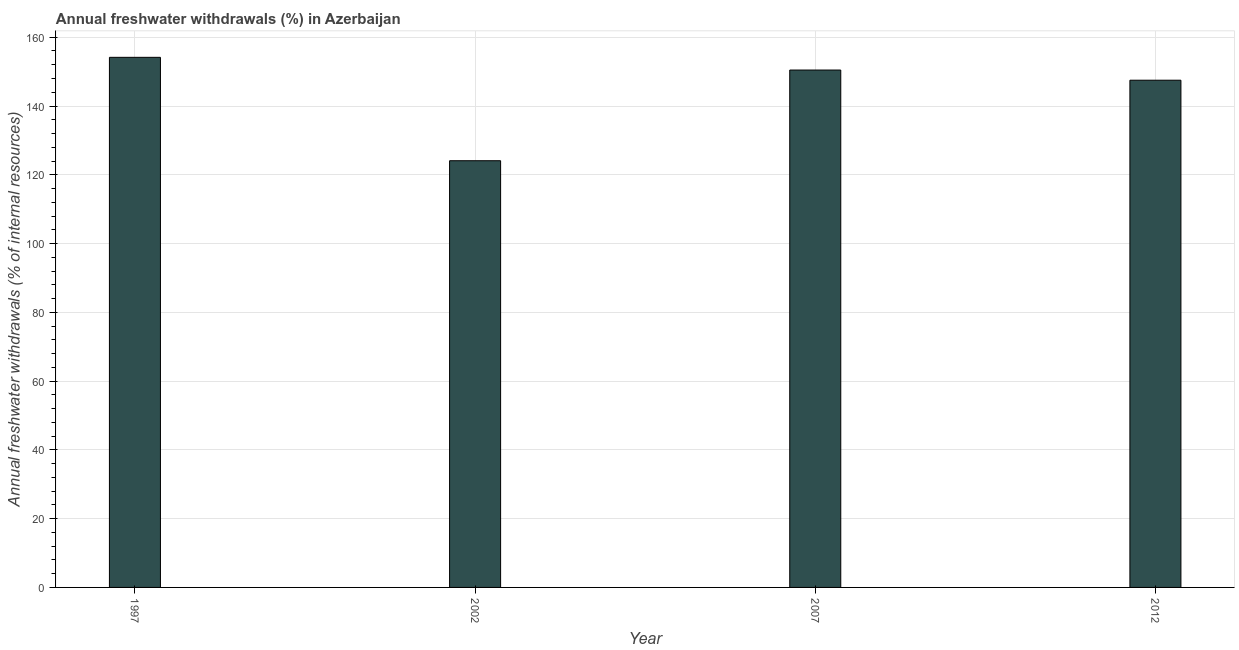Does the graph contain any zero values?
Make the answer very short. No. Does the graph contain grids?
Make the answer very short. Yes. What is the title of the graph?
Make the answer very short. Annual freshwater withdrawals (%) in Azerbaijan. What is the label or title of the Y-axis?
Make the answer very short. Annual freshwater withdrawals (% of internal resources). What is the annual freshwater withdrawals in 2002?
Offer a very short reply. 124.09. Across all years, what is the maximum annual freshwater withdrawals?
Your answer should be compact. 154.16. Across all years, what is the minimum annual freshwater withdrawals?
Give a very brief answer. 124.09. In which year was the annual freshwater withdrawals maximum?
Ensure brevity in your answer.  1997. In which year was the annual freshwater withdrawals minimum?
Your answer should be very brief. 2002. What is the sum of the annual freshwater withdrawals?
Offer a terse response. 576.22. What is the difference between the annual freshwater withdrawals in 1997 and 2012?
Your answer should be compact. 6.65. What is the average annual freshwater withdrawals per year?
Offer a very short reply. 144.05. What is the median annual freshwater withdrawals?
Your answer should be compact. 148.98. Do a majority of the years between 2002 and 2012 (inclusive) have annual freshwater withdrawals greater than 12 %?
Provide a succinct answer. Yes. What is the difference between the highest and the second highest annual freshwater withdrawals?
Keep it short and to the point. 3.7. What is the difference between the highest and the lowest annual freshwater withdrawals?
Offer a terse response. 30.07. Are all the bars in the graph horizontal?
Give a very brief answer. No. How many years are there in the graph?
Offer a very short reply. 4. What is the difference between two consecutive major ticks on the Y-axis?
Provide a succinct answer. 20. What is the Annual freshwater withdrawals (% of internal resources) in 1997?
Offer a very short reply. 154.16. What is the Annual freshwater withdrawals (% of internal resources) of 2002?
Your response must be concise. 124.09. What is the Annual freshwater withdrawals (% of internal resources) of 2007?
Keep it short and to the point. 150.46. What is the Annual freshwater withdrawals (% of internal resources) in 2012?
Keep it short and to the point. 147.5. What is the difference between the Annual freshwater withdrawals (% of internal resources) in 1997 and 2002?
Ensure brevity in your answer.  30.07. What is the difference between the Annual freshwater withdrawals (% of internal resources) in 1997 and 2007?
Provide a succinct answer. 3.7. What is the difference between the Annual freshwater withdrawals (% of internal resources) in 1997 and 2012?
Your response must be concise. 6.65. What is the difference between the Annual freshwater withdrawals (% of internal resources) in 2002 and 2007?
Keep it short and to the point. -26.37. What is the difference between the Annual freshwater withdrawals (% of internal resources) in 2002 and 2012?
Make the answer very short. -23.41. What is the difference between the Annual freshwater withdrawals (% of internal resources) in 2007 and 2012?
Make the answer very short. 2.96. What is the ratio of the Annual freshwater withdrawals (% of internal resources) in 1997 to that in 2002?
Your answer should be compact. 1.24. What is the ratio of the Annual freshwater withdrawals (% of internal resources) in 1997 to that in 2012?
Your answer should be compact. 1.04. What is the ratio of the Annual freshwater withdrawals (% of internal resources) in 2002 to that in 2007?
Offer a very short reply. 0.82. What is the ratio of the Annual freshwater withdrawals (% of internal resources) in 2002 to that in 2012?
Ensure brevity in your answer.  0.84. What is the ratio of the Annual freshwater withdrawals (% of internal resources) in 2007 to that in 2012?
Offer a very short reply. 1.02. 